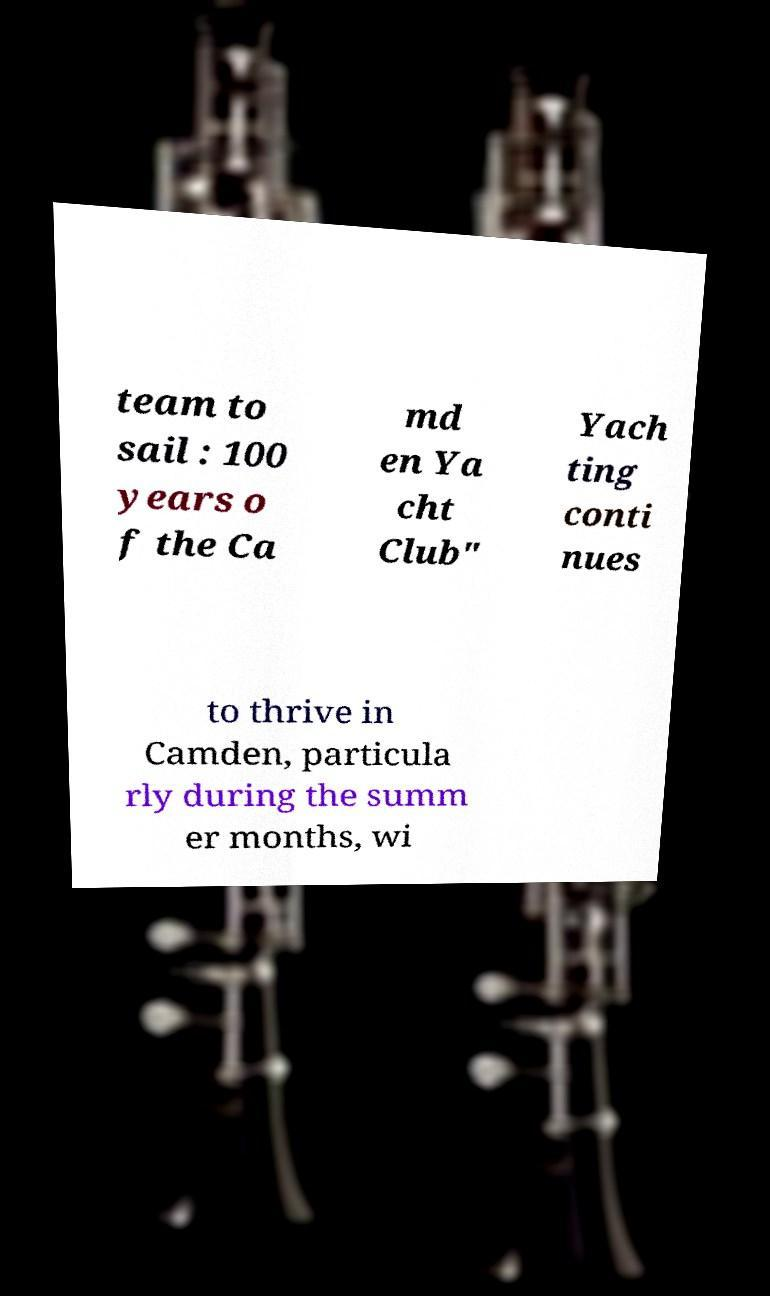Can you accurately transcribe the text from the provided image for me? team to sail : 100 years o f the Ca md en Ya cht Club" Yach ting conti nues to thrive in Camden, particula rly during the summ er months, wi 